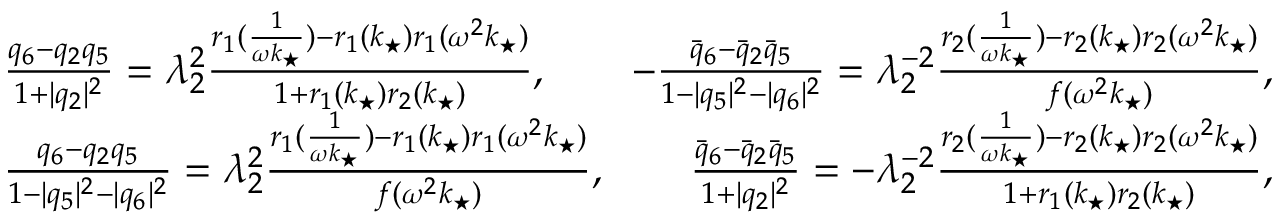Convert formula to latex. <formula><loc_0><loc_0><loc_500><loc_500>\begin{array} { r } { \frac { q _ { 6 } - q _ { 2 } q _ { 5 } } { 1 + | q _ { 2 } | ^ { 2 } } = \lambda _ { 2 } ^ { 2 } \frac { r _ { 1 } ( \frac { 1 } { \omega k _ { ^ { * } } } ) - r _ { 1 } ( k _ { ^ { * } } ) r _ { 1 } ( \omega ^ { 2 } k _ { ^ { * } } ) } { 1 + r _ { 1 } ( k _ { ^ { * } } ) r _ { 2 } ( k _ { ^ { * } } ) } , \quad - \frac { \bar { q } _ { 6 } - \bar { q } _ { 2 } \bar { q } _ { 5 } } { 1 - | q _ { 5 } | ^ { 2 } - | q _ { 6 } | ^ { 2 } } = \lambda _ { 2 } ^ { - 2 } \frac { r _ { 2 } ( \frac { 1 } { \omega k _ { ^ { * } } } ) - r _ { 2 } ( k _ { ^ { * } } ) r _ { 2 } ( \omega ^ { 2 } k _ { ^ { * } } ) } { f ( \omega ^ { 2 } k _ { ^ { * } } ) } , } \\ { \frac { q _ { 6 } - q _ { 2 } q _ { 5 } } { 1 - | q _ { 5 } | ^ { 2 } - | q _ { 6 } | ^ { 2 } } = \lambda _ { 2 } ^ { 2 } \frac { r _ { 1 } ( \frac { 1 } { \omega k _ { ^ { * } } } ) - r _ { 1 } ( k _ { ^ { * } } ) r _ { 1 } ( \omega ^ { 2 } k _ { ^ { * } } ) } { f ( \omega ^ { 2 } k _ { ^ { * } } ) } , \quad \frac { \bar { q } _ { 6 } - \bar { q } _ { 2 } \bar { q } _ { 5 } } { 1 + | q _ { 2 } | ^ { 2 } } = - \lambda _ { 2 } ^ { - 2 } \frac { r _ { 2 } ( \frac { 1 } { \omega k _ { ^ { * } } } ) - r _ { 2 } ( k _ { ^ { * } } ) r _ { 2 } ( \omega ^ { 2 } k _ { ^ { * } } ) } { 1 + r _ { 1 } ( k _ { ^ { * } } ) r _ { 2 } ( k _ { ^ { * } } ) } , } \end{array}</formula> 